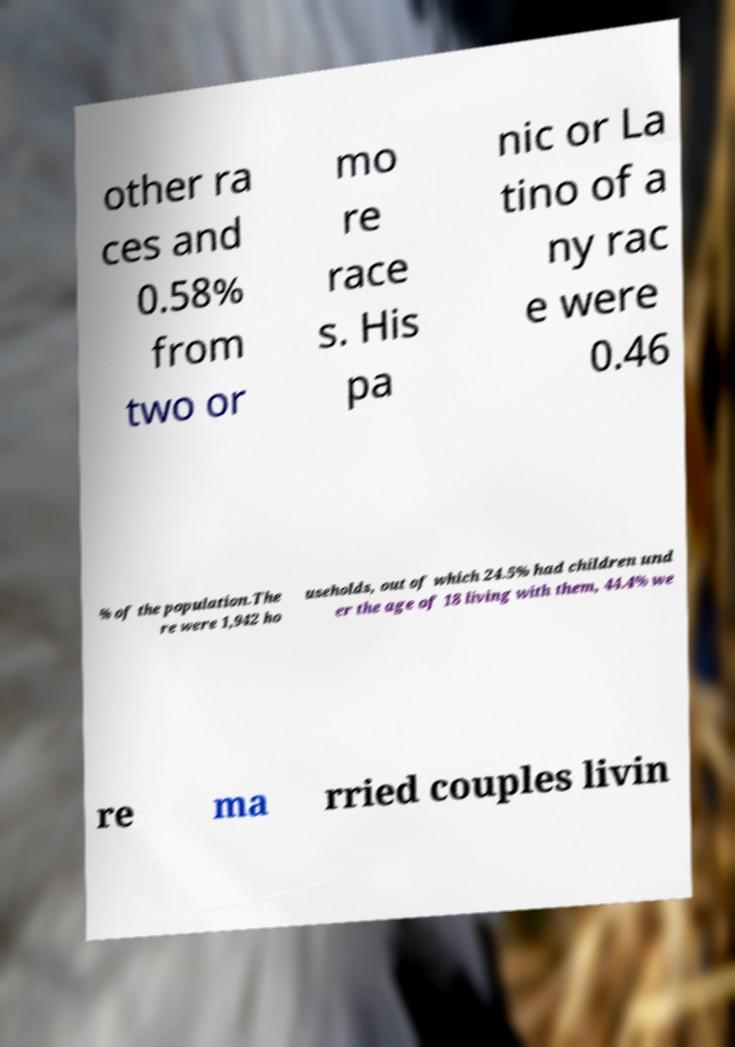Please read and relay the text visible in this image. What does it say? other ra ces and 0.58% from two or mo re race s. His pa nic or La tino of a ny rac e were 0.46 % of the population.The re were 1,942 ho useholds, out of which 24.5% had children und er the age of 18 living with them, 44.4% we re ma rried couples livin 